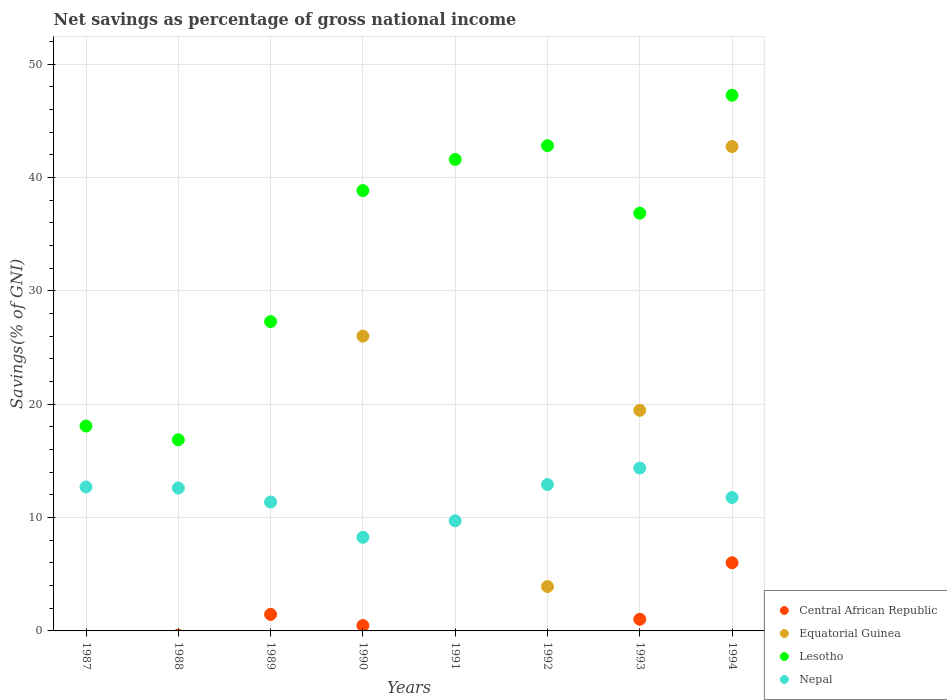Is the number of dotlines equal to the number of legend labels?
Ensure brevity in your answer.  No. Across all years, what is the maximum total savings in Lesotho?
Your answer should be very brief. 47.25. In which year was the total savings in Equatorial Guinea maximum?
Provide a short and direct response. 1994. What is the total total savings in Equatorial Guinea in the graph?
Ensure brevity in your answer.  92.11. What is the difference between the total savings in Lesotho in 1989 and that in 1990?
Your response must be concise. -11.56. What is the difference between the total savings in Nepal in 1988 and the total savings in Central African Republic in 1992?
Keep it short and to the point. 12.61. What is the average total savings in Central African Republic per year?
Give a very brief answer. 1.12. In the year 1990, what is the difference between the total savings in Nepal and total savings in Equatorial Guinea?
Ensure brevity in your answer.  -17.74. In how many years, is the total savings in Lesotho greater than 46 %?
Your answer should be very brief. 1. What is the ratio of the total savings in Nepal in 1987 to that in 1994?
Ensure brevity in your answer.  1.08. What is the difference between the highest and the second highest total savings in Central African Republic?
Your response must be concise. 4.55. What is the difference between the highest and the lowest total savings in Lesotho?
Keep it short and to the point. 30.39. Does the total savings in Nepal monotonically increase over the years?
Your answer should be compact. No. Is the total savings in Nepal strictly greater than the total savings in Central African Republic over the years?
Provide a succinct answer. Yes. How many dotlines are there?
Your response must be concise. 4. Does the graph contain any zero values?
Your answer should be very brief. Yes. Does the graph contain grids?
Offer a terse response. Yes. Where does the legend appear in the graph?
Make the answer very short. Bottom right. How many legend labels are there?
Provide a short and direct response. 4. How are the legend labels stacked?
Make the answer very short. Vertical. What is the title of the graph?
Your answer should be compact. Net savings as percentage of gross national income. Does "St. Lucia" appear as one of the legend labels in the graph?
Your response must be concise. No. What is the label or title of the Y-axis?
Provide a short and direct response. Savings(% of GNI). What is the Savings(% of GNI) of Equatorial Guinea in 1987?
Provide a succinct answer. 0. What is the Savings(% of GNI) of Lesotho in 1987?
Your answer should be very brief. 18.07. What is the Savings(% of GNI) of Nepal in 1987?
Your answer should be very brief. 12.7. What is the Savings(% of GNI) of Central African Republic in 1988?
Your answer should be very brief. 0. What is the Savings(% of GNI) of Equatorial Guinea in 1988?
Your answer should be compact. 0. What is the Savings(% of GNI) in Lesotho in 1988?
Make the answer very short. 16.86. What is the Savings(% of GNI) of Nepal in 1988?
Offer a very short reply. 12.61. What is the Savings(% of GNI) of Central African Republic in 1989?
Provide a short and direct response. 1.46. What is the Savings(% of GNI) of Equatorial Guinea in 1989?
Your response must be concise. 0. What is the Savings(% of GNI) of Lesotho in 1989?
Provide a short and direct response. 27.29. What is the Savings(% of GNI) of Nepal in 1989?
Provide a succinct answer. 11.37. What is the Savings(% of GNI) of Central African Republic in 1990?
Your response must be concise. 0.47. What is the Savings(% of GNI) of Equatorial Guinea in 1990?
Offer a terse response. 26. What is the Savings(% of GNI) in Lesotho in 1990?
Provide a short and direct response. 38.84. What is the Savings(% of GNI) in Nepal in 1990?
Keep it short and to the point. 8.26. What is the Savings(% of GNI) in Equatorial Guinea in 1991?
Provide a short and direct response. 0. What is the Savings(% of GNI) of Lesotho in 1991?
Provide a short and direct response. 41.59. What is the Savings(% of GNI) in Nepal in 1991?
Offer a very short reply. 9.71. What is the Savings(% of GNI) in Central African Republic in 1992?
Provide a succinct answer. 0. What is the Savings(% of GNI) in Equatorial Guinea in 1992?
Offer a terse response. 3.92. What is the Savings(% of GNI) in Lesotho in 1992?
Provide a succinct answer. 42.8. What is the Savings(% of GNI) in Nepal in 1992?
Make the answer very short. 12.91. What is the Savings(% of GNI) of Central African Republic in 1993?
Keep it short and to the point. 1.03. What is the Savings(% of GNI) in Equatorial Guinea in 1993?
Offer a terse response. 19.46. What is the Savings(% of GNI) of Lesotho in 1993?
Your answer should be compact. 36.85. What is the Savings(% of GNI) of Nepal in 1993?
Ensure brevity in your answer.  14.37. What is the Savings(% of GNI) in Central African Republic in 1994?
Provide a succinct answer. 6.01. What is the Savings(% of GNI) in Equatorial Guinea in 1994?
Make the answer very short. 42.73. What is the Savings(% of GNI) in Lesotho in 1994?
Give a very brief answer. 47.25. What is the Savings(% of GNI) of Nepal in 1994?
Your answer should be very brief. 11.77. Across all years, what is the maximum Savings(% of GNI) in Central African Republic?
Ensure brevity in your answer.  6.01. Across all years, what is the maximum Savings(% of GNI) of Equatorial Guinea?
Provide a short and direct response. 42.73. Across all years, what is the maximum Savings(% of GNI) in Lesotho?
Offer a very short reply. 47.25. Across all years, what is the maximum Savings(% of GNI) in Nepal?
Offer a very short reply. 14.37. Across all years, what is the minimum Savings(% of GNI) in Central African Republic?
Your answer should be compact. 0. Across all years, what is the minimum Savings(% of GNI) of Equatorial Guinea?
Keep it short and to the point. 0. Across all years, what is the minimum Savings(% of GNI) of Lesotho?
Provide a succinct answer. 16.86. Across all years, what is the minimum Savings(% of GNI) in Nepal?
Give a very brief answer. 8.26. What is the total Savings(% of GNI) in Central African Republic in the graph?
Make the answer very short. 8.97. What is the total Savings(% of GNI) of Equatorial Guinea in the graph?
Provide a succinct answer. 92.11. What is the total Savings(% of GNI) of Lesotho in the graph?
Provide a succinct answer. 269.56. What is the total Savings(% of GNI) of Nepal in the graph?
Ensure brevity in your answer.  93.69. What is the difference between the Savings(% of GNI) in Lesotho in 1987 and that in 1988?
Give a very brief answer. 1.21. What is the difference between the Savings(% of GNI) of Nepal in 1987 and that in 1988?
Provide a succinct answer. 0.09. What is the difference between the Savings(% of GNI) of Lesotho in 1987 and that in 1989?
Offer a terse response. -9.21. What is the difference between the Savings(% of GNI) in Nepal in 1987 and that in 1989?
Provide a succinct answer. 1.33. What is the difference between the Savings(% of GNI) in Lesotho in 1987 and that in 1990?
Give a very brief answer. -20.77. What is the difference between the Savings(% of GNI) of Nepal in 1987 and that in 1990?
Provide a succinct answer. 4.44. What is the difference between the Savings(% of GNI) in Lesotho in 1987 and that in 1991?
Ensure brevity in your answer.  -23.52. What is the difference between the Savings(% of GNI) in Nepal in 1987 and that in 1991?
Offer a terse response. 2.98. What is the difference between the Savings(% of GNI) in Lesotho in 1987 and that in 1992?
Your answer should be compact. -24.73. What is the difference between the Savings(% of GNI) in Nepal in 1987 and that in 1992?
Offer a terse response. -0.22. What is the difference between the Savings(% of GNI) of Lesotho in 1987 and that in 1993?
Provide a succinct answer. -18.77. What is the difference between the Savings(% of GNI) in Nepal in 1987 and that in 1993?
Give a very brief answer. -1.67. What is the difference between the Savings(% of GNI) in Lesotho in 1987 and that in 1994?
Your answer should be very brief. -29.18. What is the difference between the Savings(% of GNI) of Nepal in 1987 and that in 1994?
Give a very brief answer. 0.93. What is the difference between the Savings(% of GNI) in Lesotho in 1988 and that in 1989?
Provide a short and direct response. -10.43. What is the difference between the Savings(% of GNI) in Nepal in 1988 and that in 1989?
Ensure brevity in your answer.  1.24. What is the difference between the Savings(% of GNI) in Lesotho in 1988 and that in 1990?
Make the answer very short. -21.98. What is the difference between the Savings(% of GNI) of Nepal in 1988 and that in 1990?
Provide a short and direct response. 4.34. What is the difference between the Savings(% of GNI) in Lesotho in 1988 and that in 1991?
Your answer should be compact. -24.73. What is the difference between the Savings(% of GNI) of Nepal in 1988 and that in 1991?
Offer a terse response. 2.89. What is the difference between the Savings(% of GNI) in Lesotho in 1988 and that in 1992?
Your answer should be very brief. -25.94. What is the difference between the Savings(% of GNI) in Nepal in 1988 and that in 1992?
Keep it short and to the point. -0.31. What is the difference between the Savings(% of GNI) in Lesotho in 1988 and that in 1993?
Ensure brevity in your answer.  -19.99. What is the difference between the Savings(% of GNI) in Nepal in 1988 and that in 1993?
Keep it short and to the point. -1.76. What is the difference between the Savings(% of GNI) in Lesotho in 1988 and that in 1994?
Your response must be concise. -30.39. What is the difference between the Savings(% of GNI) in Nepal in 1988 and that in 1994?
Your answer should be compact. 0.84. What is the difference between the Savings(% of GNI) of Central African Republic in 1989 and that in 1990?
Provide a succinct answer. 0.98. What is the difference between the Savings(% of GNI) in Lesotho in 1989 and that in 1990?
Your answer should be very brief. -11.56. What is the difference between the Savings(% of GNI) of Nepal in 1989 and that in 1990?
Ensure brevity in your answer.  3.11. What is the difference between the Savings(% of GNI) of Lesotho in 1989 and that in 1991?
Provide a short and direct response. -14.3. What is the difference between the Savings(% of GNI) in Nepal in 1989 and that in 1991?
Offer a very short reply. 1.65. What is the difference between the Savings(% of GNI) of Lesotho in 1989 and that in 1992?
Offer a very short reply. -15.52. What is the difference between the Savings(% of GNI) in Nepal in 1989 and that in 1992?
Provide a short and direct response. -1.54. What is the difference between the Savings(% of GNI) of Central African Republic in 1989 and that in 1993?
Provide a succinct answer. 0.43. What is the difference between the Savings(% of GNI) of Lesotho in 1989 and that in 1993?
Offer a very short reply. -9.56. What is the difference between the Savings(% of GNI) in Nepal in 1989 and that in 1993?
Ensure brevity in your answer.  -3. What is the difference between the Savings(% of GNI) of Central African Republic in 1989 and that in 1994?
Give a very brief answer. -4.55. What is the difference between the Savings(% of GNI) in Lesotho in 1989 and that in 1994?
Provide a succinct answer. -19.97. What is the difference between the Savings(% of GNI) in Nepal in 1989 and that in 1994?
Provide a succinct answer. -0.4. What is the difference between the Savings(% of GNI) of Lesotho in 1990 and that in 1991?
Your answer should be very brief. -2.75. What is the difference between the Savings(% of GNI) in Nepal in 1990 and that in 1991?
Make the answer very short. -1.45. What is the difference between the Savings(% of GNI) of Equatorial Guinea in 1990 and that in 1992?
Ensure brevity in your answer.  22.09. What is the difference between the Savings(% of GNI) in Lesotho in 1990 and that in 1992?
Give a very brief answer. -3.96. What is the difference between the Savings(% of GNI) in Nepal in 1990 and that in 1992?
Provide a short and direct response. -4.65. What is the difference between the Savings(% of GNI) in Central African Republic in 1990 and that in 1993?
Ensure brevity in your answer.  -0.55. What is the difference between the Savings(% of GNI) of Equatorial Guinea in 1990 and that in 1993?
Keep it short and to the point. 6.54. What is the difference between the Savings(% of GNI) in Lesotho in 1990 and that in 1993?
Keep it short and to the point. 2. What is the difference between the Savings(% of GNI) in Nepal in 1990 and that in 1993?
Ensure brevity in your answer.  -6.1. What is the difference between the Savings(% of GNI) in Central African Republic in 1990 and that in 1994?
Your answer should be very brief. -5.54. What is the difference between the Savings(% of GNI) of Equatorial Guinea in 1990 and that in 1994?
Make the answer very short. -16.72. What is the difference between the Savings(% of GNI) of Lesotho in 1990 and that in 1994?
Offer a very short reply. -8.41. What is the difference between the Savings(% of GNI) of Nepal in 1990 and that in 1994?
Your answer should be compact. -3.51. What is the difference between the Savings(% of GNI) of Lesotho in 1991 and that in 1992?
Your answer should be compact. -1.22. What is the difference between the Savings(% of GNI) of Nepal in 1991 and that in 1992?
Your answer should be very brief. -3.2. What is the difference between the Savings(% of GNI) in Lesotho in 1991 and that in 1993?
Offer a very short reply. 4.74. What is the difference between the Savings(% of GNI) of Nepal in 1991 and that in 1993?
Make the answer very short. -4.65. What is the difference between the Savings(% of GNI) in Lesotho in 1991 and that in 1994?
Offer a very short reply. -5.66. What is the difference between the Savings(% of GNI) in Nepal in 1991 and that in 1994?
Ensure brevity in your answer.  -2.05. What is the difference between the Savings(% of GNI) of Equatorial Guinea in 1992 and that in 1993?
Your answer should be compact. -15.55. What is the difference between the Savings(% of GNI) in Lesotho in 1992 and that in 1993?
Make the answer very short. 5.96. What is the difference between the Savings(% of GNI) in Nepal in 1992 and that in 1993?
Provide a succinct answer. -1.45. What is the difference between the Savings(% of GNI) in Equatorial Guinea in 1992 and that in 1994?
Keep it short and to the point. -38.81. What is the difference between the Savings(% of GNI) of Lesotho in 1992 and that in 1994?
Your answer should be very brief. -4.45. What is the difference between the Savings(% of GNI) in Nepal in 1992 and that in 1994?
Ensure brevity in your answer.  1.15. What is the difference between the Savings(% of GNI) in Central African Republic in 1993 and that in 1994?
Your answer should be compact. -4.99. What is the difference between the Savings(% of GNI) of Equatorial Guinea in 1993 and that in 1994?
Provide a short and direct response. -23.27. What is the difference between the Savings(% of GNI) of Lesotho in 1993 and that in 1994?
Your answer should be compact. -10.4. What is the difference between the Savings(% of GNI) of Nepal in 1993 and that in 1994?
Your answer should be compact. 2.6. What is the difference between the Savings(% of GNI) of Lesotho in 1987 and the Savings(% of GNI) of Nepal in 1988?
Your answer should be compact. 5.47. What is the difference between the Savings(% of GNI) of Lesotho in 1987 and the Savings(% of GNI) of Nepal in 1989?
Provide a short and direct response. 6.7. What is the difference between the Savings(% of GNI) in Lesotho in 1987 and the Savings(% of GNI) in Nepal in 1990?
Make the answer very short. 9.81. What is the difference between the Savings(% of GNI) of Lesotho in 1987 and the Savings(% of GNI) of Nepal in 1991?
Make the answer very short. 8.36. What is the difference between the Savings(% of GNI) in Lesotho in 1987 and the Savings(% of GNI) in Nepal in 1992?
Keep it short and to the point. 5.16. What is the difference between the Savings(% of GNI) in Lesotho in 1987 and the Savings(% of GNI) in Nepal in 1993?
Ensure brevity in your answer.  3.71. What is the difference between the Savings(% of GNI) in Lesotho in 1987 and the Savings(% of GNI) in Nepal in 1994?
Give a very brief answer. 6.31. What is the difference between the Savings(% of GNI) of Lesotho in 1988 and the Savings(% of GNI) of Nepal in 1989?
Offer a very short reply. 5.49. What is the difference between the Savings(% of GNI) of Lesotho in 1988 and the Savings(% of GNI) of Nepal in 1990?
Provide a short and direct response. 8.6. What is the difference between the Savings(% of GNI) of Lesotho in 1988 and the Savings(% of GNI) of Nepal in 1991?
Give a very brief answer. 7.14. What is the difference between the Savings(% of GNI) of Lesotho in 1988 and the Savings(% of GNI) of Nepal in 1992?
Offer a terse response. 3.95. What is the difference between the Savings(% of GNI) of Lesotho in 1988 and the Savings(% of GNI) of Nepal in 1993?
Your response must be concise. 2.49. What is the difference between the Savings(% of GNI) of Lesotho in 1988 and the Savings(% of GNI) of Nepal in 1994?
Give a very brief answer. 5.09. What is the difference between the Savings(% of GNI) of Central African Republic in 1989 and the Savings(% of GNI) of Equatorial Guinea in 1990?
Provide a short and direct response. -24.55. What is the difference between the Savings(% of GNI) in Central African Republic in 1989 and the Savings(% of GNI) in Lesotho in 1990?
Offer a very short reply. -37.38. What is the difference between the Savings(% of GNI) in Central African Republic in 1989 and the Savings(% of GNI) in Nepal in 1990?
Offer a very short reply. -6.8. What is the difference between the Savings(% of GNI) in Lesotho in 1989 and the Savings(% of GNI) in Nepal in 1990?
Offer a very short reply. 19.03. What is the difference between the Savings(% of GNI) in Central African Republic in 1989 and the Savings(% of GNI) in Lesotho in 1991?
Give a very brief answer. -40.13. What is the difference between the Savings(% of GNI) of Central African Republic in 1989 and the Savings(% of GNI) of Nepal in 1991?
Give a very brief answer. -8.26. What is the difference between the Savings(% of GNI) of Lesotho in 1989 and the Savings(% of GNI) of Nepal in 1991?
Make the answer very short. 17.57. What is the difference between the Savings(% of GNI) of Central African Republic in 1989 and the Savings(% of GNI) of Equatorial Guinea in 1992?
Your answer should be very brief. -2.46. What is the difference between the Savings(% of GNI) of Central African Republic in 1989 and the Savings(% of GNI) of Lesotho in 1992?
Your response must be concise. -41.35. What is the difference between the Savings(% of GNI) of Central African Republic in 1989 and the Savings(% of GNI) of Nepal in 1992?
Your answer should be compact. -11.45. What is the difference between the Savings(% of GNI) in Lesotho in 1989 and the Savings(% of GNI) in Nepal in 1992?
Keep it short and to the point. 14.37. What is the difference between the Savings(% of GNI) in Central African Republic in 1989 and the Savings(% of GNI) in Equatorial Guinea in 1993?
Offer a very short reply. -18. What is the difference between the Savings(% of GNI) of Central African Republic in 1989 and the Savings(% of GNI) of Lesotho in 1993?
Give a very brief answer. -35.39. What is the difference between the Savings(% of GNI) in Central African Republic in 1989 and the Savings(% of GNI) in Nepal in 1993?
Offer a terse response. -12.91. What is the difference between the Savings(% of GNI) of Lesotho in 1989 and the Savings(% of GNI) of Nepal in 1993?
Your response must be concise. 12.92. What is the difference between the Savings(% of GNI) in Central African Republic in 1989 and the Savings(% of GNI) in Equatorial Guinea in 1994?
Give a very brief answer. -41.27. What is the difference between the Savings(% of GNI) of Central African Republic in 1989 and the Savings(% of GNI) of Lesotho in 1994?
Offer a very short reply. -45.79. What is the difference between the Savings(% of GNI) of Central African Republic in 1989 and the Savings(% of GNI) of Nepal in 1994?
Keep it short and to the point. -10.31. What is the difference between the Savings(% of GNI) in Lesotho in 1989 and the Savings(% of GNI) in Nepal in 1994?
Your response must be concise. 15.52. What is the difference between the Savings(% of GNI) of Central African Republic in 1990 and the Savings(% of GNI) of Lesotho in 1991?
Make the answer very short. -41.11. What is the difference between the Savings(% of GNI) of Central African Republic in 1990 and the Savings(% of GNI) of Nepal in 1991?
Your answer should be very brief. -9.24. What is the difference between the Savings(% of GNI) of Equatorial Guinea in 1990 and the Savings(% of GNI) of Lesotho in 1991?
Your answer should be compact. -15.58. What is the difference between the Savings(% of GNI) in Equatorial Guinea in 1990 and the Savings(% of GNI) in Nepal in 1991?
Offer a very short reply. 16.29. What is the difference between the Savings(% of GNI) of Lesotho in 1990 and the Savings(% of GNI) of Nepal in 1991?
Your response must be concise. 29.13. What is the difference between the Savings(% of GNI) in Central African Republic in 1990 and the Savings(% of GNI) in Equatorial Guinea in 1992?
Provide a succinct answer. -3.44. What is the difference between the Savings(% of GNI) in Central African Republic in 1990 and the Savings(% of GNI) in Lesotho in 1992?
Your response must be concise. -42.33. What is the difference between the Savings(% of GNI) of Central African Republic in 1990 and the Savings(% of GNI) of Nepal in 1992?
Ensure brevity in your answer.  -12.44. What is the difference between the Savings(% of GNI) in Equatorial Guinea in 1990 and the Savings(% of GNI) in Lesotho in 1992?
Your answer should be compact. -16.8. What is the difference between the Savings(% of GNI) in Equatorial Guinea in 1990 and the Savings(% of GNI) in Nepal in 1992?
Your answer should be very brief. 13.09. What is the difference between the Savings(% of GNI) of Lesotho in 1990 and the Savings(% of GNI) of Nepal in 1992?
Offer a very short reply. 25.93. What is the difference between the Savings(% of GNI) of Central African Republic in 1990 and the Savings(% of GNI) of Equatorial Guinea in 1993?
Provide a short and direct response. -18.99. What is the difference between the Savings(% of GNI) of Central African Republic in 1990 and the Savings(% of GNI) of Lesotho in 1993?
Provide a short and direct response. -36.37. What is the difference between the Savings(% of GNI) of Central African Republic in 1990 and the Savings(% of GNI) of Nepal in 1993?
Ensure brevity in your answer.  -13.89. What is the difference between the Savings(% of GNI) in Equatorial Guinea in 1990 and the Savings(% of GNI) in Lesotho in 1993?
Provide a short and direct response. -10.84. What is the difference between the Savings(% of GNI) of Equatorial Guinea in 1990 and the Savings(% of GNI) of Nepal in 1993?
Offer a very short reply. 11.64. What is the difference between the Savings(% of GNI) of Lesotho in 1990 and the Savings(% of GNI) of Nepal in 1993?
Provide a succinct answer. 24.48. What is the difference between the Savings(% of GNI) in Central African Republic in 1990 and the Savings(% of GNI) in Equatorial Guinea in 1994?
Make the answer very short. -42.25. What is the difference between the Savings(% of GNI) in Central African Republic in 1990 and the Savings(% of GNI) in Lesotho in 1994?
Provide a short and direct response. -46.78. What is the difference between the Savings(% of GNI) in Central African Republic in 1990 and the Savings(% of GNI) in Nepal in 1994?
Your answer should be compact. -11.29. What is the difference between the Savings(% of GNI) of Equatorial Guinea in 1990 and the Savings(% of GNI) of Lesotho in 1994?
Provide a short and direct response. -21.25. What is the difference between the Savings(% of GNI) of Equatorial Guinea in 1990 and the Savings(% of GNI) of Nepal in 1994?
Offer a terse response. 14.24. What is the difference between the Savings(% of GNI) in Lesotho in 1990 and the Savings(% of GNI) in Nepal in 1994?
Offer a very short reply. 27.08. What is the difference between the Savings(% of GNI) of Lesotho in 1991 and the Savings(% of GNI) of Nepal in 1992?
Ensure brevity in your answer.  28.68. What is the difference between the Savings(% of GNI) in Lesotho in 1991 and the Savings(% of GNI) in Nepal in 1993?
Your answer should be compact. 27.22. What is the difference between the Savings(% of GNI) of Lesotho in 1991 and the Savings(% of GNI) of Nepal in 1994?
Your answer should be very brief. 29.82. What is the difference between the Savings(% of GNI) in Equatorial Guinea in 1992 and the Savings(% of GNI) in Lesotho in 1993?
Make the answer very short. -32.93. What is the difference between the Savings(% of GNI) in Equatorial Guinea in 1992 and the Savings(% of GNI) in Nepal in 1993?
Make the answer very short. -10.45. What is the difference between the Savings(% of GNI) of Lesotho in 1992 and the Savings(% of GNI) of Nepal in 1993?
Offer a very short reply. 28.44. What is the difference between the Savings(% of GNI) in Equatorial Guinea in 1992 and the Savings(% of GNI) in Lesotho in 1994?
Provide a short and direct response. -43.34. What is the difference between the Savings(% of GNI) of Equatorial Guinea in 1992 and the Savings(% of GNI) of Nepal in 1994?
Your answer should be very brief. -7.85. What is the difference between the Savings(% of GNI) of Lesotho in 1992 and the Savings(% of GNI) of Nepal in 1994?
Your response must be concise. 31.04. What is the difference between the Savings(% of GNI) of Central African Republic in 1993 and the Savings(% of GNI) of Equatorial Guinea in 1994?
Provide a short and direct response. -41.7. What is the difference between the Savings(% of GNI) in Central African Republic in 1993 and the Savings(% of GNI) in Lesotho in 1994?
Your answer should be compact. -46.23. What is the difference between the Savings(% of GNI) of Central African Republic in 1993 and the Savings(% of GNI) of Nepal in 1994?
Offer a very short reply. -10.74. What is the difference between the Savings(% of GNI) of Equatorial Guinea in 1993 and the Savings(% of GNI) of Lesotho in 1994?
Offer a very short reply. -27.79. What is the difference between the Savings(% of GNI) of Equatorial Guinea in 1993 and the Savings(% of GNI) of Nepal in 1994?
Your answer should be very brief. 7.69. What is the difference between the Savings(% of GNI) in Lesotho in 1993 and the Savings(% of GNI) in Nepal in 1994?
Offer a terse response. 25.08. What is the average Savings(% of GNI) in Central African Republic per year?
Your response must be concise. 1.12. What is the average Savings(% of GNI) of Equatorial Guinea per year?
Your response must be concise. 11.51. What is the average Savings(% of GNI) in Lesotho per year?
Your answer should be very brief. 33.69. What is the average Savings(% of GNI) in Nepal per year?
Offer a very short reply. 11.71. In the year 1987, what is the difference between the Savings(% of GNI) of Lesotho and Savings(% of GNI) of Nepal?
Offer a very short reply. 5.38. In the year 1988, what is the difference between the Savings(% of GNI) of Lesotho and Savings(% of GNI) of Nepal?
Make the answer very short. 4.25. In the year 1989, what is the difference between the Savings(% of GNI) in Central African Republic and Savings(% of GNI) in Lesotho?
Give a very brief answer. -25.83. In the year 1989, what is the difference between the Savings(% of GNI) in Central African Republic and Savings(% of GNI) in Nepal?
Your response must be concise. -9.91. In the year 1989, what is the difference between the Savings(% of GNI) of Lesotho and Savings(% of GNI) of Nepal?
Offer a terse response. 15.92. In the year 1990, what is the difference between the Savings(% of GNI) in Central African Republic and Savings(% of GNI) in Equatorial Guinea?
Make the answer very short. -25.53. In the year 1990, what is the difference between the Savings(% of GNI) of Central African Republic and Savings(% of GNI) of Lesotho?
Make the answer very short. -38.37. In the year 1990, what is the difference between the Savings(% of GNI) of Central African Republic and Savings(% of GNI) of Nepal?
Your answer should be compact. -7.79. In the year 1990, what is the difference between the Savings(% of GNI) of Equatorial Guinea and Savings(% of GNI) of Lesotho?
Your response must be concise. -12.84. In the year 1990, what is the difference between the Savings(% of GNI) in Equatorial Guinea and Savings(% of GNI) in Nepal?
Offer a very short reply. 17.74. In the year 1990, what is the difference between the Savings(% of GNI) in Lesotho and Savings(% of GNI) in Nepal?
Offer a terse response. 30.58. In the year 1991, what is the difference between the Savings(% of GNI) in Lesotho and Savings(% of GNI) in Nepal?
Your response must be concise. 31.87. In the year 1992, what is the difference between the Savings(% of GNI) of Equatorial Guinea and Savings(% of GNI) of Lesotho?
Offer a terse response. -38.89. In the year 1992, what is the difference between the Savings(% of GNI) of Equatorial Guinea and Savings(% of GNI) of Nepal?
Make the answer very short. -9. In the year 1992, what is the difference between the Savings(% of GNI) of Lesotho and Savings(% of GNI) of Nepal?
Offer a very short reply. 29.89. In the year 1993, what is the difference between the Savings(% of GNI) of Central African Republic and Savings(% of GNI) of Equatorial Guinea?
Provide a succinct answer. -18.43. In the year 1993, what is the difference between the Savings(% of GNI) in Central African Republic and Savings(% of GNI) in Lesotho?
Keep it short and to the point. -35.82. In the year 1993, what is the difference between the Savings(% of GNI) in Central African Republic and Savings(% of GNI) in Nepal?
Offer a terse response. -13.34. In the year 1993, what is the difference between the Savings(% of GNI) of Equatorial Guinea and Savings(% of GNI) of Lesotho?
Give a very brief answer. -17.39. In the year 1993, what is the difference between the Savings(% of GNI) of Equatorial Guinea and Savings(% of GNI) of Nepal?
Offer a very short reply. 5.1. In the year 1993, what is the difference between the Savings(% of GNI) of Lesotho and Savings(% of GNI) of Nepal?
Make the answer very short. 22.48. In the year 1994, what is the difference between the Savings(% of GNI) of Central African Republic and Savings(% of GNI) of Equatorial Guinea?
Make the answer very short. -36.71. In the year 1994, what is the difference between the Savings(% of GNI) of Central African Republic and Savings(% of GNI) of Lesotho?
Provide a short and direct response. -41.24. In the year 1994, what is the difference between the Savings(% of GNI) in Central African Republic and Savings(% of GNI) in Nepal?
Ensure brevity in your answer.  -5.75. In the year 1994, what is the difference between the Savings(% of GNI) of Equatorial Guinea and Savings(% of GNI) of Lesotho?
Make the answer very short. -4.53. In the year 1994, what is the difference between the Savings(% of GNI) in Equatorial Guinea and Savings(% of GNI) in Nepal?
Offer a very short reply. 30.96. In the year 1994, what is the difference between the Savings(% of GNI) of Lesotho and Savings(% of GNI) of Nepal?
Your answer should be very brief. 35.48. What is the ratio of the Savings(% of GNI) in Lesotho in 1987 to that in 1988?
Your answer should be compact. 1.07. What is the ratio of the Savings(% of GNI) in Nepal in 1987 to that in 1988?
Provide a succinct answer. 1.01. What is the ratio of the Savings(% of GNI) in Lesotho in 1987 to that in 1989?
Your response must be concise. 0.66. What is the ratio of the Savings(% of GNI) in Nepal in 1987 to that in 1989?
Offer a terse response. 1.12. What is the ratio of the Savings(% of GNI) of Lesotho in 1987 to that in 1990?
Offer a very short reply. 0.47. What is the ratio of the Savings(% of GNI) of Nepal in 1987 to that in 1990?
Make the answer very short. 1.54. What is the ratio of the Savings(% of GNI) of Lesotho in 1987 to that in 1991?
Make the answer very short. 0.43. What is the ratio of the Savings(% of GNI) of Nepal in 1987 to that in 1991?
Your answer should be very brief. 1.31. What is the ratio of the Savings(% of GNI) in Lesotho in 1987 to that in 1992?
Make the answer very short. 0.42. What is the ratio of the Savings(% of GNI) in Nepal in 1987 to that in 1992?
Make the answer very short. 0.98. What is the ratio of the Savings(% of GNI) in Lesotho in 1987 to that in 1993?
Keep it short and to the point. 0.49. What is the ratio of the Savings(% of GNI) in Nepal in 1987 to that in 1993?
Offer a very short reply. 0.88. What is the ratio of the Savings(% of GNI) of Lesotho in 1987 to that in 1994?
Provide a short and direct response. 0.38. What is the ratio of the Savings(% of GNI) in Nepal in 1987 to that in 1994?
Ensure brevity in your answer.  1.08. What is the ratio of the Savings(% of GNI) in Lesotho in 1988 to that in 1989?
Provide a succinct answer. 0.62. What is the ratio of the Savings(% of GNI) in Nepal in 1988 to that in 1989?
Offer a terse response. 1.11. What is the ratio of the Savings(% of GNI) in Lesotho in 1988 to that in 1990?
Your answer should be compact. 0.43. What is the ratio of the Savings(% of GNI) of Nepal in 1988 to that in 1990?
Ensure brevity in your answer.  1.53. What is the ratio of the Savings(% of GNI) of Lesotho in 1988 to that in 1991?
Provide a succinct answer. 0.41. What is the ratio of the Savings(% of GNI) in Nepal in 1988 to that in 1991?
Your answer should be compact. 1.3. What is the ratio of the Savings(% of GNI) of Lesotho in 1988 to that in 1992?
Your answer should be compact. 0.39. What is the ratio of the Savings(% of GNI) in Nepal in 1988 to that in 1992?
Keep it short and to the point. 0.98. What is the ratio of the Savings(% of GNI) in Lesotho in 1988 to that in 1993?
Offer a terse response. 0.46. What is the ratio of the Savings(% of GNI) in Nepal in 1988 to that in 1993?
Your response must be concise. 0.88. What is the ratio of the Savings(% of GNI) in Lesotho in 1988 to that in 1994?
Keep it short and to the point. 0.36. What is the ratio of the Savings(% of GNI) of Nepal in 1988 to that in 1994?
Provide a short and direct response. 1.07. What is the ratio of the Savings(% of GNI) in Central African Republic in 1989 to that in 1990?
Your answer should be compact. 3.08. What is the ratio of the Savings(% of GNI) in Lesotho in 1989 to that in 1990?
Offer a terse response. 0.7. What is the ratio of the Savings(% of GNI) of Nepal in 1989 to that in 1990?
Make the answer very short. 1.38. What is the ratio of the Savings(% of GNI) of Lesotho in 1989 to that in 1991?
Provide a succinct answer. 0.66. What is the ratio of the Savings(% of GNI) in Nepal in 1989 to that in 1991?
Your answer should be very brief. 1.17. What is the ratio of the Savings(% of GNI) in Lesotho in 1989 to that in 1992?
Offer a very short reply. 0.64. What is the ratio of the Savings(% of GNI) of Nepal in 1989 to that in 1992?
Your response must be concise. 0.88. What is the ratio of the Savings(% of GNI) in Central African Republic in 1989 to that in 1993?
Your answer should be compact. 1.42. What is the ratio of the Savings(% of GNI) in Lesotho in 1989 to that in 1993?
Provide a short and direct response. 0.74. What is the ratio of the Savings(% of GNI) of Nepal in 1989 to that in 1993?
Give a very brief answer. 0.79. What is the ratio of the Savings(% of GNI) of Central African Republic in 1989 to that in 1994?
Offer a terse response. 0.24. What is the ratio of the Savings(% of GNI) in Lesotho in 1989 to that in 1994?
Your answer should be compact. 0.58. What is the ratio of the Savings(% of GNI) of Nepal in 1989 to that in 1994?
Make the answer very short. 0.97. What is the ratio of the Savings(% of GNI) of Lesotho in 1990 to that in 1991?
Provide a succinct answer. 0.93. What is the ratio of the Savings(% of GNI) in Nepal in 1990 to that in 1991?
Your answer should be very brief. 0.85. What is the ratio of the Savings(% of GNI) of Equatorial Guinea in 1990 to that in 1992?
Offer a very short reply. 6.64. What is the ratio of the Savings(% of GNI) of Lesotho in 1990 to that in 1992?
Keep it short and to the point. 0.91. What is the ratio of the Savings(% of GNI) in Nepal in 1990 to that in 1992?
Provide a succinct answer. 0.64. What is the ratio of the Savings(% of GNI) of Central African Republic in 1990 to that in 1993?
Keep it short and to the point. 0.46. What is the ratio of the Savings(% of GNI) of Equatorial Guinea in 1990 to that in 1993?
Your answer should be very brief. 1.34. What is the ratio of the Savings(% of GNI) of Lesotho in 1990 to that in 1993?
Your response must be concise. 1.05. What is the ratio of the Savings(% of GNI) in Nepal in 1990 to that in 1993?
Ensure brevity in your answer.  0.57. What is the ratio of the Savings(% of GNI) of Central African Republic in 1990 to that in 1994?
Your answer should be compact. 0.08. What is the ratio of the Savings(% of GNI) in Equatorial Guinea in 1990 to that in 1994?
Provide a succinct answer. 0.61. What is the ratio of the Savings(% of GNI) in Lesotho in 1990 to that in 1994?
Your answer should be compact. 0.82. What is the ratio of the Savings(% of GNI) of Nepal in 1990 to that in 1994?
Offer a terse response. 0.7. What is the ratio of the Savings(% of GNI) of Lesotho in 1991 to that in 1992?
Keep it short and to the point. 0.97. What is the ratio of the Savings(% of GNI) in Nepal in 1991 to that in 1992?
Keep it short and to the point. 0.75. What is the ratio of the Savings(% of GNI) of Lesotho in 1991 to that in 1993?
Your answer should be very brief. 1.13. What is the ratio of the Savings(% of GNI) of Nepal in 1991 to that in 1993?
Provide a succinct answer. 0.68. What is the ratio of the Savings(% of GNI) in Lesotho in 1991 to that in 1994?
Make the answer very short. 0.88. What is the ratio of the Savings(% of GNI) of Nepal in 1991 to that in 1994?
Your answer should be very brief. 0.83. What is the ratio of the Savings(% of GNI) of Equatorial Guinea in 1992 to that in 1993?
Provide a succinct answer. 0.2. What is the ratio of the Savings(% of GNI) in Lesotho in 1992 to that in 1993?
Your answer should be very brief. 1.16. What is the ratio of the Savings(% of GNI) of Nepal in 1992 to that in 1993?
Provide a short and direct response. 0.9. What is the ratio of the Savings(% of GNI) in Equatorial Guinea in 1992 to that in 1994?
Offer a very short reply. 0.09. What is the ratio of the Savings(% of GNI) of Lesotho in 1992 to that in 1994?
Your answer should be compact. 0.91. What is the ratio of the Savings(% of GNI) in Nepal in 1992 to that in 1994?
Offer a terse response. 1.1. What is the ratio of the Savings(% of GNI) in Central African Republic in 1993 to that in 1994?
Provide a short and direct response. 0.17. What is the ratio of the Savings(% of GNI) in Equatorial Guinea in 1993 to that in 1994?
Make the answer very short. 0.46. What is the ratio of the Savings(% of GNI) in Lesotho in 1993 to that in 1994?
Offer a very short reply. 0.78. What is the ratio of the Savings(% of GNI) of Nepal in 1993 to that in 1994?
Your answer should be very brief. 1.22. What is the difference between the highest and the second highest Savings(% of GNI) in Central African Republic?
Provide a short and direct response. 4.55. What is the difference between the highest and the second highest Savings(% of GNI) in Equatorial Guinea?
Make the answer very short. 16.72. What is the difference between the highest and the second highest Savings(% of GNI) in Lesotho?
Your response must be concise. 4.45. What is the difference between the highest and the second highest Savings(% of GNI) of Nepal?
Your answer should be compact. 1.45. What is the difference between the highest and the lowest Savings(% of GNI) in Central African Republic?
Provide a succinct answer. 6.01. What is the difference between the highest and the lowest Savings(% of GNI) of Equatorial Guinea?
Keep it short and to the point. 42.73. What is the difference between the highest and the lowest Savings(% of GNI) of Lesotho?
Provide a succinct answer. 30.39. What is the difference between the highest and the lowest Savings(% of GNI) of Nepal?
Provide a succinct answer. 6.1. 